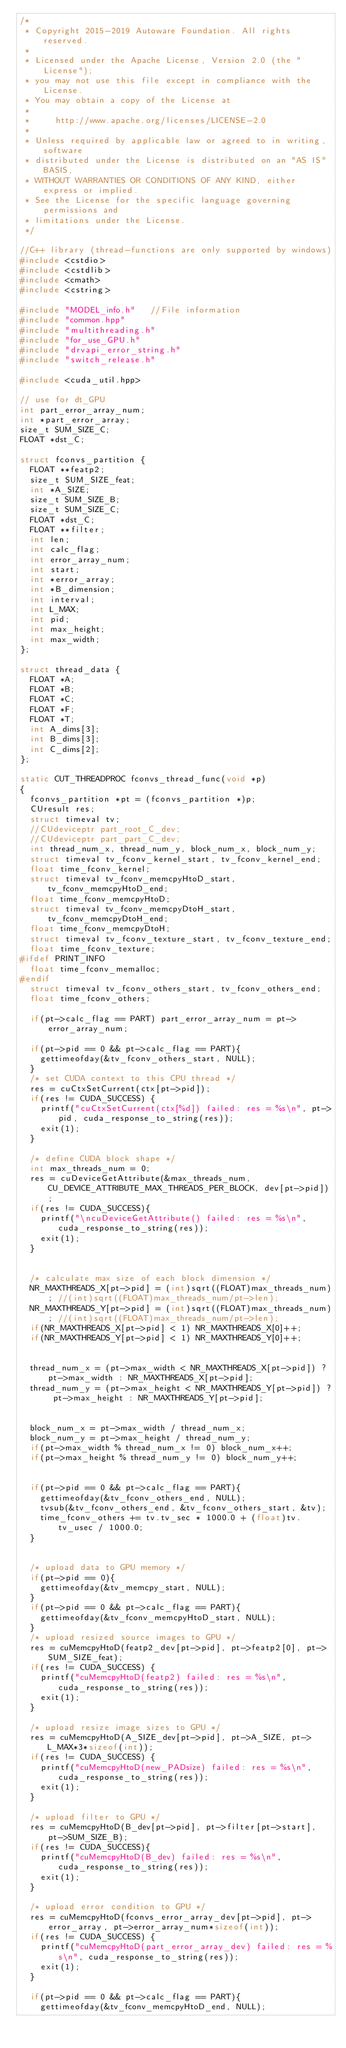<code> <loc_0><loc_0><loc_500><loc_500><_C++_>/*
 * Copyright 2015-2019 Autoware Foundation. All rights reserved.
 *
 * Licensed under the Apache License, Version 2.0 (the "License");
 * you may not use this file except in compliance with the License.
 * You may obtain a copy of the License at
 *
 *     http://www.apache.org/licenses/LICENSE-2.0
 *
 * Unless required by applicable law or agreed to in writing, software
 * distributed under the License is distributed on an "AS IS" BASIS,
 * WITHOUT WARRANTIES OR CONDITIONS OF ANY KIND, either express or implied.
 * See the License for the specific language governing permissions and
 * limitations under the License.
 */

//C++ library (thread-functions are only supported by windows)
#include <cstdio>
#include <cstdlib>
#include <cmath>
#include <cstring>

#include "MODEL_info.h"		//File information
#include "common.hpp"
#include "multithreading.h"
#include "for_use_GPU.h"
#include "drvapi_error_string.h"
#include "switch_release.h"

#include <cuda_util.hpp>

// use for dt_GPU
int part_error_array_num;
int *part_error_array;
size_t SUM_SIZE_C;
FLOAT *dst_C;

struct fconvs_partition {
	FLOAT **featp2;
	size_t SUM_SIZE_feat;
	int *A_SIZE;
	size_t SUM_SIZE_B;
	size_t SUM_SIZE_C;
	FLOAT *dst_C;
	FLOAT **filter;
	int len;
	int calc_flag;
	int error_array_num;
	int start;
	int *error_array;
	int *B_dimension;
	int interval;
	int L_MAX;
	int pid;
	int max_height;
	int max_width;
};

struct thread_data {
	FLOAT *A;
	FLOAT *B;
	FLOAT *C;
	FLOAT *F;
	FLOAT *T;
	int A_dims[3];
	int B_dims[3];
	int C_dims[2];
};

static CUT_THREADPROC fconvs_thread_func(void *p)
{
	fconvs_partition *pt = (fconvs_partition *)p;
	CUresult res;
	struct timeval tv;
	//CUdeviceptr part_root_C_dev;
	//CUdeviceptr part_part_C_dev;
	int thread_num_x, thread_num_y, block_num_x, block_num_y;
	struct timeval tv_fconv_kernel_start, tv_fconv_kernel_end;
	float time_fconv_kernel;
	struct timeval tv_fconv_memcpyHtoD_start, tv_fconv_memcpyHtoD_end;
	float time_fconv_memcpyHtoD;
	struct timeval tv_fconv_memcpyDtoH_start, tv_fconv_memcpyDtoH_end;
	float time_fconv_memcpyDtoH;
	struct timeval tv_fconv_texture_start, tv_fconv_texture_end;
	float time_fconv_texture;
#ifdef PRINT_INFO
	float time_fconv_memalloc;
#endif
	struct timeval tv_fconv_others_start, tv_fconv_others_end;
	float time_fconv_others;

	if(pt->calc_flag == PART) part_error_array_num = pt->error_array_num;

	if(pt->pid == 0 && pt->calc_flag == PART){
		gettimeofday(&tv_fconv_others_start, NULL);
	}
	/* set CUDA context to this CPU thread */
	res = cuCtxSetCurrent(ctx[pt->pid]);
	if(res != CUDA_SUCCESS) {
		printf("cuCtxSetCurrent(ctx[%d]) failed: res = %s\n", pt->pid, cuda_response_to_string(res));
		exit(1);
	}

	/* define CUDA block shape */
	int max_threads_num = 0;
	res = cuDeviceGetAttribute(&max_threads_num, CU_DEVICE_ATTRIBUTE_MAX_THREADS_PER_BLOCK, dev[pt->pid]);
	if(res != CUDA_SUCCESS){
		printf("\ncuDeviceGetAttribute() failed: res = %s\n", cuda_response_to_string(res));
		exit(1);
	}


	/* calculate max size of each block dimension */
	NR_MAXTHREADS_X[pt->pid] = (int)sqrt((FLOAT)max_threads_num); //(int)sqrt((FLOAT)max_threads_num/pt->len);
	NR_MAXTHREADS_Y[pt->pid] = (int)sqrt((FLOAT)max_threads_num); //(int)sqrt((FLOAT)max_threads_num/pt->len);
	if(NR_MAXTHREADS_X[pt->pid] < 1) NR_MAXTHREADS_X[0]++;
	if(NR_MAXTHREADS_Y[pt->pid] < 1) NR_MAXTHREADS_Y[0]++;


	thread_num_x = (pt->max_width < NR_MAXTHREADS_X[pt->pid]) ? pt->max_width : NR_MAXTHREADS_X[pt->pid];
	thread_num_y = (pt->max_height < NR_MAXTHREADS_Y[pt->pid]) ? pt->max_height : NR_MAXTHREADS_Y[pt->pid];


	block_num_x = pt->max_width / thread_num_x;
	block_num_y = pt->max_height / thread_num_y;
	if(pt->max_width % thread_num_x != 0) block_num_x++;
	if(pt->max_height % thread_num_y != 0) block_num_y++;


	if(pt->pid == 0 && pt->calc_flag == PART){
		gettimeofday(&tv_fconv_others_end, NULL);
		tvsub(&tv_fconv_others_end, &tv_fconv_others_start, &tv);
		time_fconv_others += tv.tv_sec * 1000.0 + (float)tv.tv_usec / 1000.0;
	}


	/* upload data to GPU memory */
	if(pt->pid == 0){
		gettimeofday(&tv_memcpy_start, NULL);
	}
	if(pt->pid == 0 && pt->calc_flag == PART){
		gettimeofday(&tv_fconv_memcpyHtoD_start, NULL);
	}
	/* upload resized source images to GPU */
	res = cuMemcpyHtoD(featp2_dev[pt->pid], pt->featp2[0], pt->SUM_SIZE_feat);
	if(res != CUDA_SUCCESS) {
		printf("cuMemcpyHtoD(featp2) failed: res = %s\n", cuda_response_to_string(res));
		exit(1);
	}

	/* upload resize image sizes to GPU */
	res = cuMemcpyHtoD(A_SIZE_dev[pt->pid], pt->A_SIZE, pt->L_MAX*3*sizeof(int));
	if(res != CUDA_SUCCESS) {
		printf("cuMemcpyHtoD(new_PADsize) failed: res = %s\n", cuda_response_to_string(res));
		exit(1);
	}

	/* upload filter to GPU */
	res = cuMemcpyHtoD(B_dev[pt->pid], pt->filter[pt->start],  pt->SUM_SIZE_B);
	if(res != CUDA_SUCCESS){
		printf("cuMemcpyHtoD(B_dev) failed: res = %s\n", cuda_response_to_string(res));
		exit(1);
	}

	/* upload error condition to GPU */
	res = cuMemcpyHtoD(fconvs_error_array_dev[pt->pid], pt->error_array, pt->error_array_num*sizeof(int));
	if(res != CUDA_SUCCESS) {
		printf("cuMemcpyHtoD(part_error_array_dev) failed: res = %s\n", cuda_response_to_string(res));
		exit(1);
	}

	if(pt->pid == 0 && pt->calc_flag == PART){
		gettimeofday(&tv_fconv_memcpyHtoD_end, NULL);</code> 